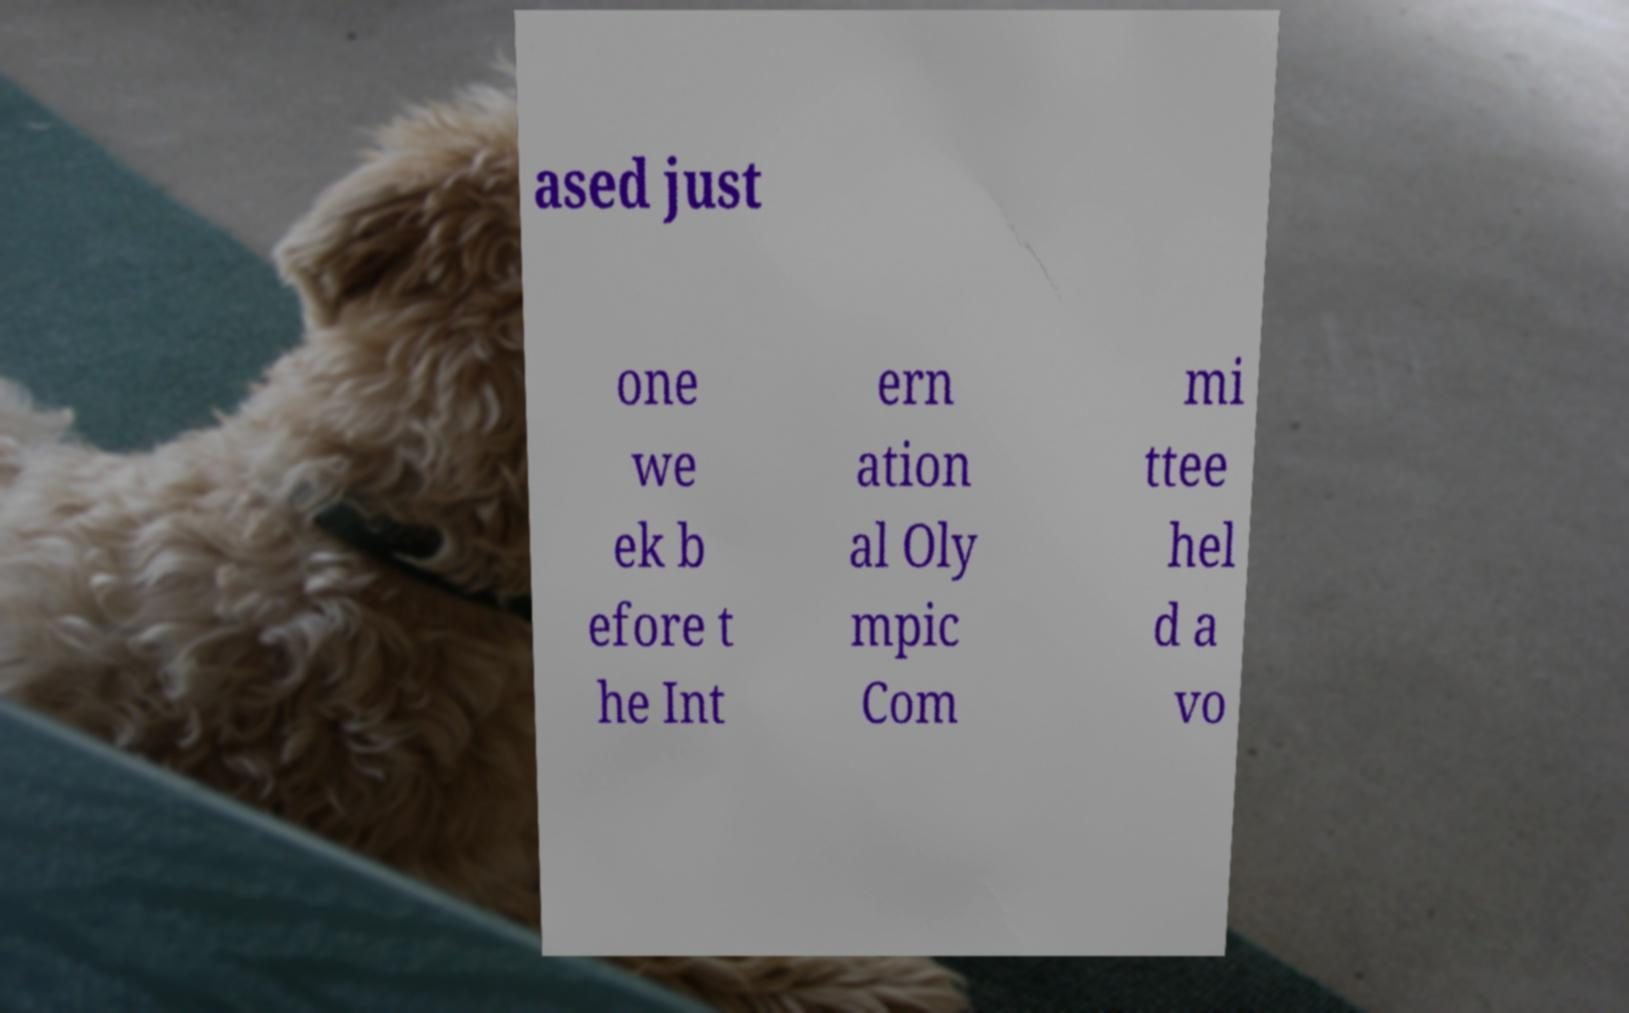Could you extract and type out the text from this image? ased just one we ek b efore t he Int ern ation al Oly mpic Com mi ttee hel d a vo 